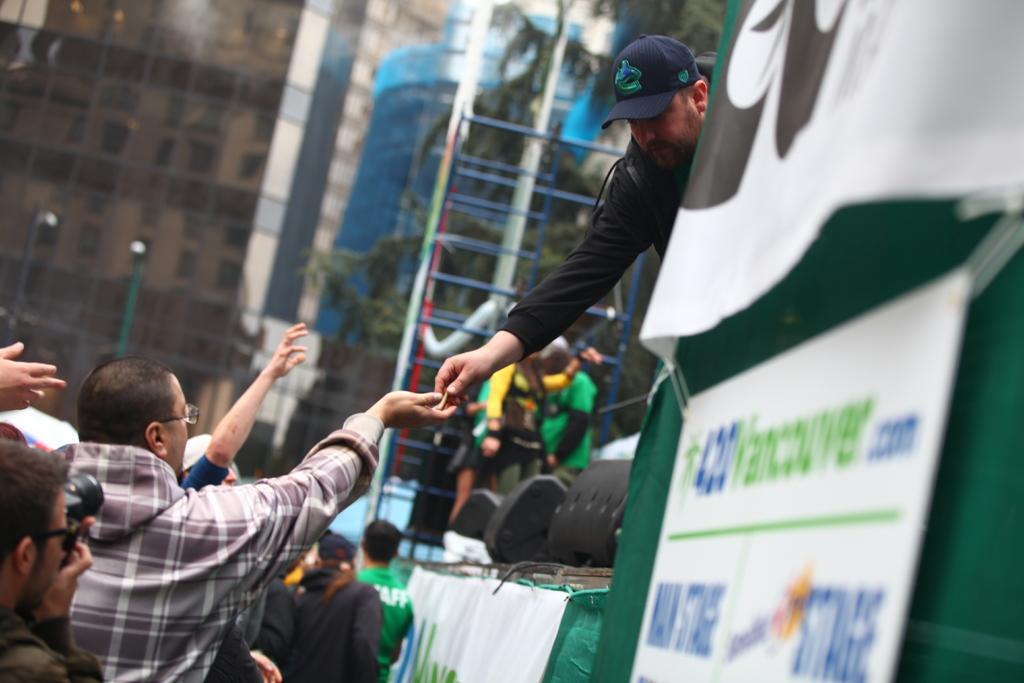How would you summarize this image in a sentence or two? In this image there are few people on the road, few people on the ladder, a person and black color objects on the stage, there are buildings and a tree. 